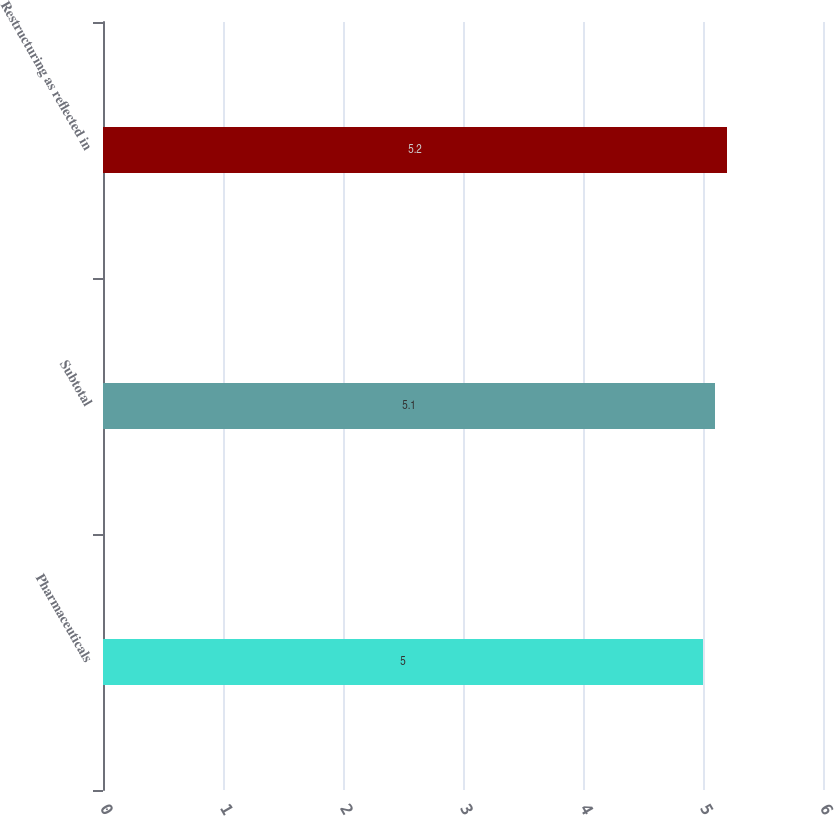<chart> <loc_0><loc_0><loc_500><loc_500><bar_chart><fcel>Pharmaceuticals<fcel>Subtotal<fcel>Restructuring as reflected in<nl><fcel>5<fcel>5.1<fcel>5.2<nl></chart> 